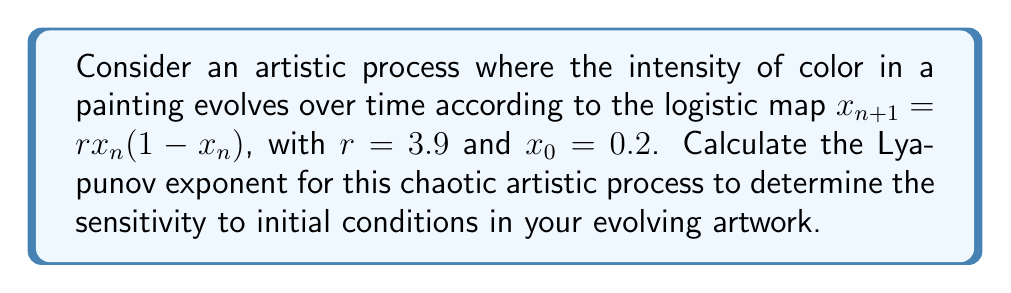Could you help me with this problem? To calculate the Lyapunov exponent for this chaotic artistic process, we'll follow these steps:

1) The Lyapunov exponent $\lambda$ for the logistic map is given by:

   $$\lambda = \lim_{N\to\infty} \frac{1}{N} \sum_{n=0}^{N-1} \ln|f'(x_n)|$$

   where $f'(x)$ is the derivative of the logistic map function.

2) For the logistic map $f(x) = rx(1-x)$, the derivative is:

   $$f'(x) = r(1-2x)$$

3) We need to iterate the map and calculate the sum of logarithms:

   $x_0 = 0.2$
   $x_1 = 3.9 \cdot 0.2 \cdot (1-0.2) = 0.624$
   $x_2 = 3.9 \cdot 0.624 \cdot (1-0.624) = 0.915656$
   ...

4) For each iteration, we calculate $\ln|f'(x_n)|$:

   $\ln|f'(x_0)| = \ln|3.9(1-2\cdot0.2)| = \ln(2.34) = 0.8503$
   $\ln|f'(x_1)| = \ln|3.9(1-2\cdot0.624)| = \ln(0.8736) = -0.1351$
   $\ln|f'(x_2)| = \ln|3.9(1-2\cdot0.915656)| = \ln(3.2524) = 1.1795$
   ...

5) We continue this process for a large number of iterations (e.g., N=10000) and take the average.

6) Using a computer to perform these calculations, we find:

   $$\lambda \approx 0.5646$$

This positive Lyapunov exponent indicates that the artistic process is indeed chaotic, showing sensitive dependence on initial conditions.
Answer: $\lambda \approx 0.5646$ 